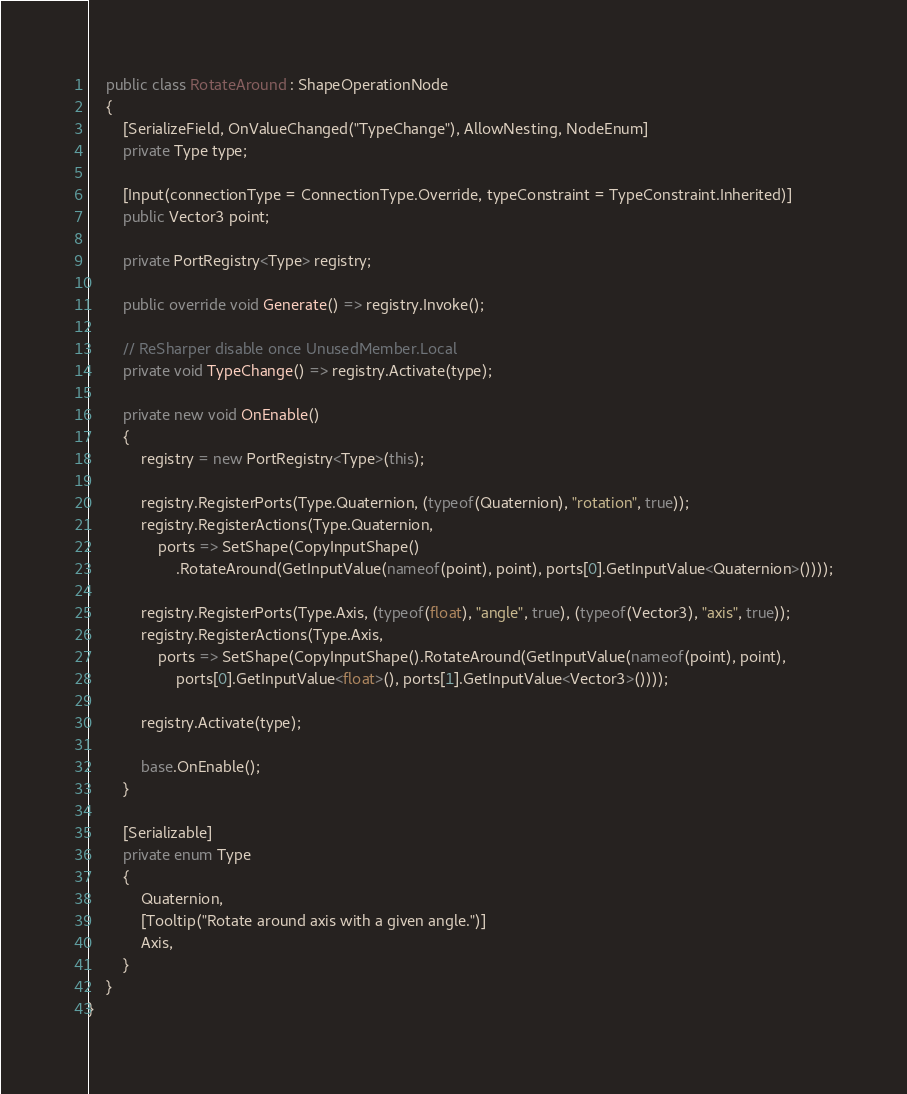<code> <loc_0><loc_0><loc_500><loc_500><_C#_>    public class RotateAround : ShapeOperationNode
    {
        [SerializeField, OnValueChanged("TypeChange"), AllowNesting, NodeEnum]
        private Type type;

        [Input(connectionType = ConnectionType.Override, typeConstraint = TypeConstraint.Inherited)]
        public Vector3 point;
        
        private PortRegistry<Type> registry;
        
        public override void Generate() => registry.Invoke();

        // ReSharper disable once UnusedMember.Local
        private void TypeChange() => registry.Activate(type);
        
        private new void OnEnable()
        {
            registry = new PortRegistry<Type>(this);
            
            registry.RegisterPorts(Type.Quaternion, (typeof(Quaternion), "rotation", true));
            registry.RegisterActions(Type.Quaternion,
                ports => SetShape(CopyInputShape()
                    .RotateAround(GetInputValue(nameof(point), point), ports[0].GetInputValue<Quaternion>())));
            
            registry.RegisterPorts(Type.Axis, (typeof(float), "angle", true), (typeof(Vector3), "axis", true));
            registry.RegisterActions(Type.Axis,
                ports => SetShape(CopyInputShape().RotateAround(GetInputValue(nameof(point), point),
                    ports[0].GetInputValue<float>(), ports[1].GetInputValue<Vector3>())));
            
            registry.Activate(type);
            
            base.OnEnable();
        }
        
        [Serializable]
        private enum Type
        {
            Quaternion,
            [Tooltip("Rotate around axis with a given angle.")]
            Axis,
        }
    }
}</code> 